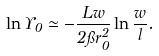<formula> <loc_0><loc_0><loc_500><loc_500>\ln \Upsilon _ { 0 } \simeq - \frac { L w } { 2 \pi r _ { 0 } ^ { 2 } } \ln \frac { w } { l } .</formula> 